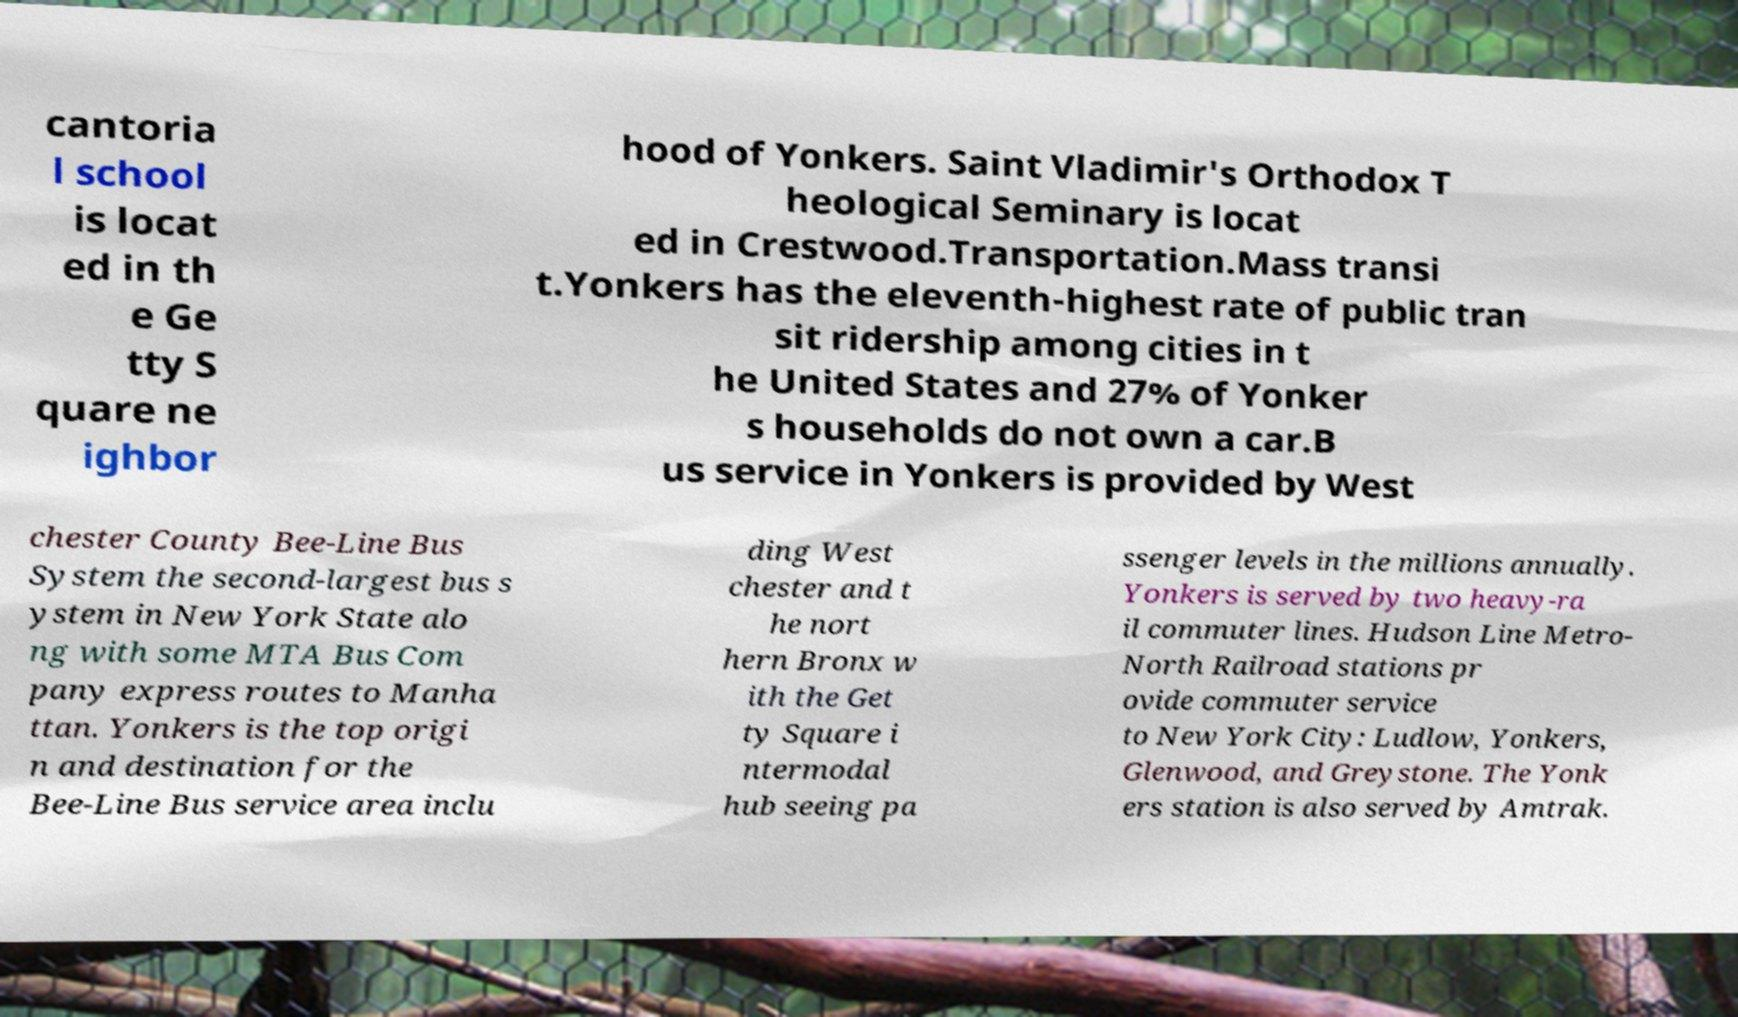What messages or text are displayed in this image? I need them in a readable, typed format. cantoria l school is locat ed in th e Ge tty S quare ne ighbor hood of Yonkers. Saint Vladimir's Orthodox T heological Seminary is locat ed in Crestwood.Transportation.Mass transi t.Yonkers has the eleventh-highest rate of public tran sit ridership among cities in t he United States and 27% of Yonker s households do not own a car.B us service in Yonkers is provided by West chester County Bee-Line Bus System the second-largest bus s ystem in New York State alo ng with some MTA Bus Com pany express routes to Manha ttan. Yonkers is the top origi n and destination for the Bee-Line Bus service area inclu ding West chester and t he nort hern Bronx w ith the Get ty Square i ntermodal hub seeing pa ssenger levels in the millions annually. Yonkers is served by two heavy-ra il commuter lines. Hudson Line Metro- North Railroad stations pr ovide commuter service to New York City: Ludlow, Yonkers, Glenwood, and Greystone. The Yonk ers station is also served by Amtrak. 